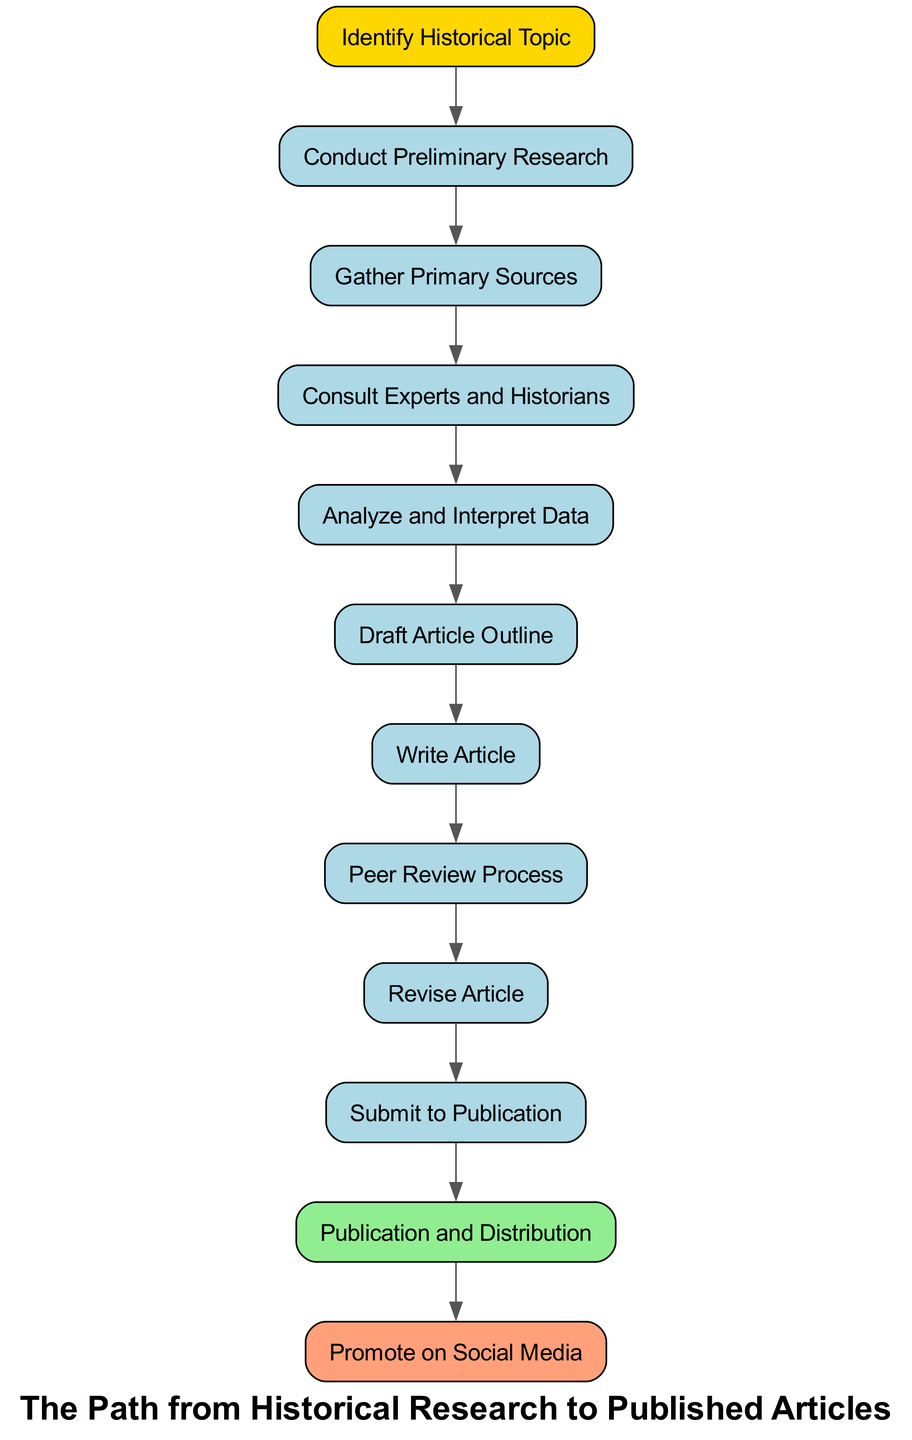What is the first step in the flow chart? The first step is represented by the node labeled "Identify Historical Topic." This is clearly indicated as the starting point of the diagram, thus it is the first action in the research process.
Answer: Identify Historical Topic How many steps are involved in the flow chart? By counting the nodes in the diagram, there are 12 steps, including the final action of promoting the article on social media. Each labeled node represents a unique step in the process.
Answer: 12 What is the final step in the flow chart? The last step is indicated by the node labeled "Promote on Social Media," clearly marked as the end action after publication and distribution of the article.
Answer: Promote on Social Media Which step comes after "Analyze and Interpret Data"? Following the "Analyze and Interpret Data" node, which is step five, the next step is "Draft Article Outline." This directly follows in the flow of the diagram as the subsequent action.
Answer: Draft Article Outline How many nodes connect to "Revise Article"? The "Revise Article" step connects from only one previous node, which is "Peer Review Process." It shows the workflow where revisions are made after undergoing peer review.
Answer: 1 Is "Consult Experts and Historians" before or after "Gather Primary Sources"? "Consult Experts and Historians" occurs after "Gather Primary Sources." Therefore, if one traces the flow, it becomes clear that gathering sources precedes consulting experts.
Answer: After Which step directly precedes publication? The step that comes immediately before "Publication and Distribution" is "Submit to Publication." This clearly shows the progression from submission to publication within the flow.
Answer: Submit to Publication What color represents the starting point in the diagram? The starting point labeled "Identify Historical Topic" is filled with a golden yellow color, distinguishing it from other nodes in the diagram.
Answer: Golden Yellow How many edges are there in the flow chart? There are 11 edges connecting the 12 nodes, as each connection represents a step to the next, leading from start to finish in a single flow.
Answer: 11 